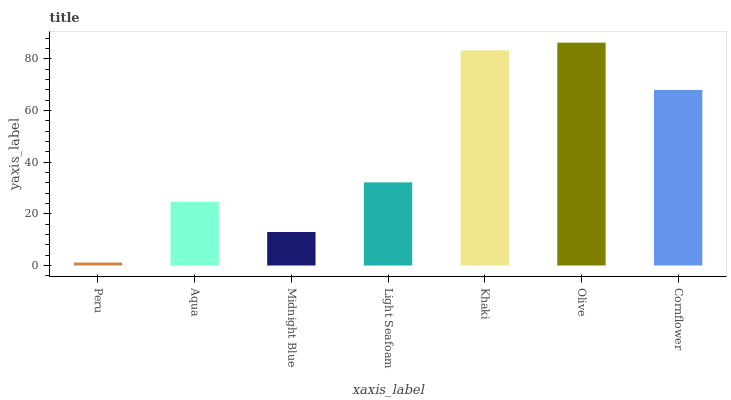Is Peru the minimum?
Answer yes or no. Yes. Is Olive the maximum?
Answer yes or no. Yes. Is Aqua the minimum?
Answer yes or no. No. Is Aqua the maximum?
Answer yes or no. No. Is Aqua greater than Peru?
Answer yes or no. Yes. Is Peru less than Aqua?
Answer yes or no. Yes. Is Peru greater than Aqua?
Answer yes or no. No. Is Aqua less than Peru?
Answer yes or no. No. Is Light Seafoam the high median?
Answer yes or no. Yes. Is Light Seafoam the low median?
Answer yes or no. Yes. Is Midnight Blue the high median?
Answer yes or no. No. Is Aqua the low median?
Answer yes or no. No. 